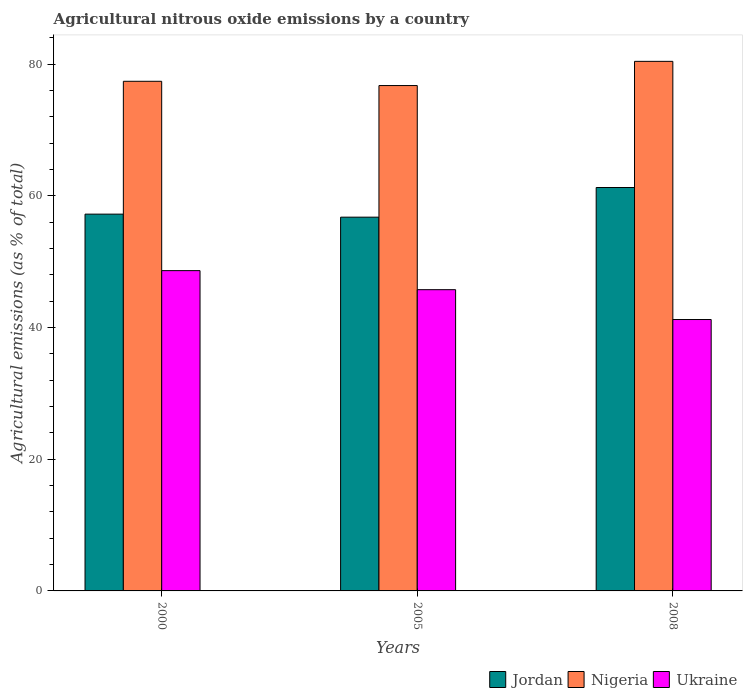Are the number of bars per tick equal to the number of legend labels?
Your response must be concise. Yes. Are the number of bars on each tick of the X-axis equal?
Ensure brevity in your answer.  Yes. What is the label of the 2nd group of bars from the left?
Ensure brevity in your answer.  2005. What is the amount of agricultural nitrous oxide emitted in Ukraine in 2008?
Your response must be concise. 41.21. Across all years, what is the maximum amount of agricultural nitrous oxide emitted in Nigeria?
Your response must be concise. 80.42. Across all years, what is the minimum amount of agricultural nitrous oxide emitted in Jordan?
Your response must be concise. 56.76. In which year was the amount of agricultural nitrous oxide emitted in Ukraine maximum?
Offer a very short reply. 2000. What is the total amount of agricultural nitrous oxide emitted in Jordan in the graph?
Provide a succinct answer. 175.24. What is the difference between the amount of agricultural nitrous oxide emitted in Nigeria in 2005 and that in 2008?
Offer a terse response. -3.68. What is the difference between the amount of agricultural nitrous oxide emitted in Nigeria in 2008 and the amount of agricultural nitrous oxide emitted in Ukraine in 2000?
Your response must be concise. 31.78. What is the average amount of agricultural nitrous oxide emitted in Jordan per year?
Your answer should be compact. 58.41. In the year 2008, what is the difference between the amount of agricultural nitrous oxide emitted in Ukraine and amount of agricultural nitrous oxide emitted in Nigeria?
Offer a terse response. -39.2. In how many years, is the amount of agricultural nitrous oxide emitted in Ukraine greater than 20 %?
Your answer should be very brief. 3. What is the ratio of the amount of agricultural nitrous oxide emitted in Nigeria in 2005 to that in 2008?
Make the answer very short. 0.95. Is the amount of agricultural nitrous oxide emitted in Ukraine in 2005 less than that in 2008?
Keep it short and to the point. No. What is the difference between the highest and the second highest amount of agricultural nitrous oxide emitted in Nigeria?
Offer a very short reply. 3.03. What is the difference between the highest and the lowest amount of agricultural nitrous oxide emitted in Jordan?
Provide a short and direct response. 4.5. In how many years, is the amount of agricultural nitrous oxide emitted in Jordan greater than the average amount of agricultural nitrous oxide emitted in Jordan taken over all years?
Your answer should be compact. 1. Is the sum of the amount of agricultural nitrous oxide emitted in Jordan in 2000 and 2008 greater than the maximum amount of agricultural nitrous oxide emitted in Ukraine across all years?
Your response must be concise. Yes. What does the 3rd bar from the left in 2005 represents?
Ensure brevity in your answer.  Ukraine. What does the 3rd bar from the right in 2008 represents?
Make the answer very short. Jordan. Is it the case that in every year, the sum of the amount of agricultural nitrous oxide emitted in Nigeria and amount of agricultural nitrous oxide emitted in Ukraine is greater than the amount of agricultural nitrous oxide emitted in Jordan?
Provide a succinct answer. Yes. How many bars are there?
Offer a terse response. 9. Are all the bars in the graph horizontal?
Make the answer very short. No. What is the difference between two consecutive major ticks on the Y-axis?
Your answer should be compact. 20. Does the graph contain grids?
Your answer should be very brief. No. How are the legend labels stacked?
Make the answer very short. Horizontal. What is the title of the graph?
Provide a short and direct response. Agricultural nitrous oxide emissions by a country. Does "China" appear as one of the legend labels in the graph?
Ensure brevity in your answer.  No. What is the label or title of the X-axis?
Provide a short and direct response. Years. What is the label or title of the Y-axis?
Keep it short and to the point. Agricultural emissions (as % of total). What is the Agricultural emissions (as % of total) of Jordan in 2000?
Offer a very short reply. 57.22. What is the Agricultural emissions (as % of total) of Nigeria in 2000?
Ensure brevity in your answer.  77.39. What is the Agricultural emissions (as % of total) of Ukraine in 2000?
Keep it short and to the point. 48.64. What is the Agricultural emissions (as % of total) in Jordan in 2005?
Your answer should be compact. 56.76. What is the Agricultural emissions (as % of total) in Nigeria in 2005?
Offer a terse response. 76.74. What is the Agricultural emissions (as % of total) of Ukraine in 2005?
Provide a succinct answer. 45.75. What is the Agricultural emissions (as % of total) of Jordan in 2008?
Your response must be concise. 61.26. What is the Agricultural emissions (as % of total) in Nigeria in 2008?
Your answer should be compact. 80.42. What is the Agricultural emissions (as % of total) in Ukraine in 2008?
Your answer should be compact. 41.21. Across all years, what is the maximum Agricultural emissions (as % of total) in Jordan?
Ensure brevity in your answer.  61.26. Across all years, what is the maximum Agricultural emissions (as % of total) of Nigeria?
Offer a terse response. 80.42. Across all years, what is the maximum Agricultural emissions (as % of total) in Ukraine?
Make the answer very short. 48.64. Across all years, what is the minimum Agricultural emissions (as % of total) of Jordan?
Your answer should be very brief. 56.76. Across all years, what is the minimum Agricultural emissions (as % of total) of Nigeria?
Your answer should be very brief. 76.74. Across all years, what is the minimum Agricultural emissions (as % of total) of Ukraine?
Provide a succinct answer. 41.21. What is the total Agricultural emissions (as % of total) of Jordan in the graph?
Make the answer very short. 175.24. What is the total Agricultural emissions (as % of total) of Nigeria in the graph?
Offer a terse response. 234.55. What is the total Agricultural emissions (as % of total) of Ukraine in the graph?
Your answer should be compact. 135.6. What is the difference between the Agricultural emissions (as % of total) of Jordan in 2000 and that in 2005?
Give a very brief answer. 0.46. What is the difference between the Agricultural emissions (as % of total) in Nigeria in 2000 and that in 2005?
Make the answer very short. 0.65. What is the difference between the Agricultural emissions (as % of total) in Ukraine in 2000 and that in 2005?
Offer a very short reply. 2.89. What is the difference between the Agricultural emissions (as % of total) of Jordan in 2000 and that in 2008?
Ensure brevity in your answer.  -4.04. What is the difference between the Agricultural emissions (as % of total) of Nigeria in 2000 and that in 2008?
Your answer should be very brief. -3.03. What is the difference between the Agricultural emissions (as % of total) of Ukraine in 2000 and that in 2008?
Provide a short and direct response. 7.42. What is the difference between the Agricultural emissions (as % of total) in Jordan in 2005 and that in 2008?
Your answer should be compact. -4.5. What is the difference between the Agricultural emissions (as % of total) in Nigeria in 2005 and that in 2008?
Your response must be concise. -3.68. What is the difference between the Agricultural emissions (as % of total) in Ukraine in 2005 and that in 2008?
Your response must be concise. 4.53. What is the difference between the Agricultural emissions (as % of total) in Jordan in 2000 and the Agricultural emissions (as % of total) in Nigeria in 2005?
Offer a very short reply. -19.53. What is the difference between the Agricultural emissions (as % of total) of Jordan in 2000 and the Agricultural emissions (as % of total) of Ukraine in 2005?
Give a very brief answer. 11.47. What is the difference between the Agricultural emissions (as % of total) of Nigeria in 2000 and the Agricultural emissions (as % of total) of Ukraine in 2005?
Keep it short and to the point. 31.65. What is the difference between the Agricultural emissions (as % of total) in Jordan in 2000 and the Agricultural emissions (as % of total) in Nigeria in 2008?
Offer a terse response. -23.2. What is the difference between the Agricultural emissions (as % of total) in Jordan in 2000 and the Agricultural emissions (as % of total) in Ukraine in 2008?
Your answer should be compact. 16. What is the difference between the Agricultural emissions (as % of total) in Nigeria in 2000 and the Agricultural emissions (as % of total) in Ukraine in 2008?
Your response must be concise. 36.18. What is the difference between the Agricultural emissions (as % of total) in Jordan in 2005 and the Agricultural emissions (as % of total) in Nigeria in 2008?
Provide a short and direct response. -23.66. What is the difference between the Agricultural emissions (as % of total) of Jordan in 2005 and the Agricultural emissions (as % of total) of Ukraine in 2008?
Ensure brevity in your answer.  15.54. What is the difference between the Agricultural emissions (as % of total) of Nigeria in 2005 and the Agricultural emissions (as % of total) of Ukraine in 2008?
Offer a terse response. 35.53. What is the average Agricultural emissions (as % of total) of Jordan per year?
Keep it short and to the point. 58.41. What is the average Agricultural emissions (as % of total) of Nigeria per year?
Give a very brief answer. 78.18. What is the average Agricultural emissions (as % of total) in Ukraine per year?
Your answer should be compact. 45.2. In the year 2000, what is the difference between the Agricultural emissions (as % of total) of Jordan and Agricultural emissions (as % of total) of Nigeria?
Give a very brief answer. -20.17. In the year 2000, what is the difference between the Agricultural emissions (as % of total) in Jordan and Agricultural emissions (as % of total) in Ukraine?
Provide a short and direct response. 8.58. In the year 2000, what is the difference between the Agricultural emissions (as % of total) in Nigeria and Agricultural emissions (as % of total) in Ukraine?
Offer a terse response. 28.75. In the year 2005, what is the difference between the Agricultural emissions (as % of total) in Jordan and Agricultural emissions (as % of total) in Nigeria?
Provide a short and direct response. -19.98. In the year 2005, what is the difference between the Agricultural emissions (as % of total) of Jordan and Agricultural emissions (as % of total) of Ukraine?
Give a very brief answer. 11.01. In the year 2005, what is the difference between the Agricultural emissions (as % of total) of Nigeria and Agricultural emissions (as % of total) of Ukraine?
Ensure brevity in your answer.  31. In the year 2008, what is the difference between the Agricultural emissions (as % of total) of Jordan and Agricultural emissions (as % of total) of Nigeria?
Make the answer very short. -19.16. In the year 2008, what is the difference between the Agricultural emissions (as % of total) of Jordan and Agricultural emissions (as % of total) of Ukraine?
Offer a terse response. 20.05. In the year 2008, what is the difference between the Agricultural emissions (as % of total) of Nigeria and Agricultural emissions (as % of total) of Ukraine?
Provide a succinct answer. 39.2. What is the ratio of the Agricultural emissions (as % of total) of Nigeria in 2000 to that in 2005?
Your answer should be very brief. 1.01. What is the ratio of the Agricultural emissions (as % of total) of Ukraine in 2000 to that in 2005?
Your response must be concise. 1.06. What is the ratio of the Agricultural emissions (as % of total) in Jordan in 2000 to that in 2008?
Offer a very short reply. 0.93. What is the ratio of the Agricultural emissions (as % of total) of Nigeria in 2000 to that in 2008?
Ensure brevity in your answer.  0.96. What is the ratio of the Agricultural emissions (as % of total) of Ukraine in 2000 to that in 2008?
Offer a terse response. 1.18. What is the ratio of the Agricultural emissions (as % of total) of Jordan in 2005 to that in 2008?
Provide a short and direct response. 0.93. What is the ratio of the Agricultural emissions (as % of total) of Nigeria in 2005 to that in 2008?
Provide a succinct answer. 0.95. What is the ratio of the Agricultural emissions (as % of total) in Ukraine in 2005 to that in 2008?
Your response must be concise. 1.11. What is the difference between the highest and the second highest Agricultural emissions (as % of total) in Jordan?
Your answer should be very brief. 4.04. What is the difference between the highest and the second highest Agricultural emissions (as % of total) of Nigeria?
Provide a succinct answer. 3.03. What is the difference between the highest and the second highest Agricultural emissions (as % of total) of Ukraine?
Give a very brief answer. 2.89. What is the difference between the highest and the lowest Agricultural emissions (as % of total) in Jordan?
Give a very brief answer. 4.5. What is the difference between the highest and the lowest Agricultural emissions (as % of total) of Nigeria?
Offer a terse response. 3.68. What is the difference between the highest and the lowest Agricultural emissions (as % of total) of Ukraine?
Make the answer very short. 7.42. 